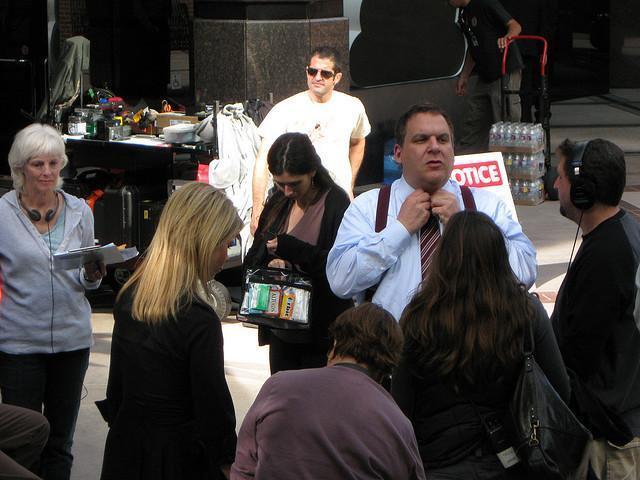How many suitcases are in the picture?
Give a very brief answer. 2. How many handbags are in the photo?
Give a very brief answer. 2. How many people are visible?
Give a very brief answer. 10. 